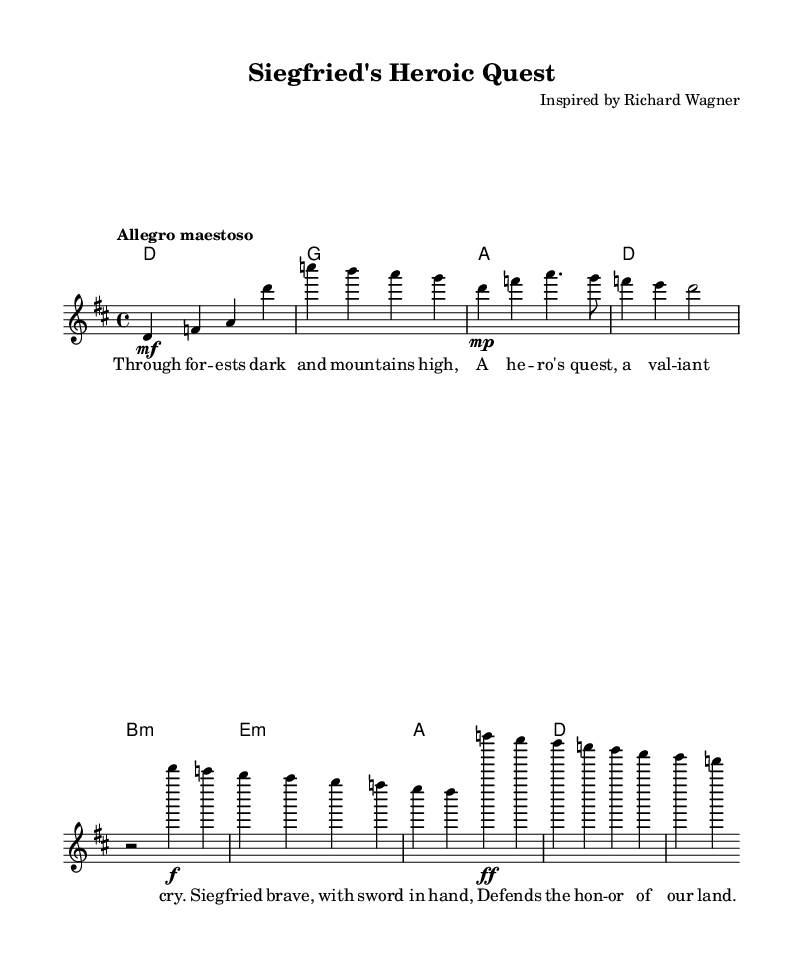What is the key signature of this music? The key signature is indicated at the beginning of the score before the staff and it shows two sharps, which represent D major.
Answer: D major What is the time signature of this piece? The time signature is noted at the beginning of the score and is represented as a fraction; here it shows four beats per measure.
Answer: 4/4 What is the tempo marking for this piece? The tempo marking appears above the staff and it indicates that the music should be played "Allegro maestoso", which signifies a fast and majestic performance.
Answer: Allegro maestoso How many bars does the introduction have? The introduction consists of the first segment of the melody. Counting the notes, we can see that there are two measures played in the introduction.
Answer: 2 What is the dynamic marking for the first verse? The first verse has a dynamic marking of "mp" which indicates that the music should be played moderately soft.
Answer: mp What character does this opera focus on? The lyrics and title suggest that the opera focuses on Siegfried, a heroic character known for bravery in Germanic mythology.
Answer: Siegfried What is the overall theme reflected in the chorus? The chorus portrays a message of honor and valor, emphasizing Siegfried's bravery and his defense of his homeland.
Answer: Honor and valor 